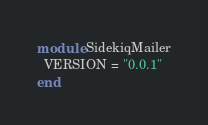<code> <loc_0><loc_0><loc_500><loc_500><_Ruby_>module SidekiqMailer
  VERSION = "0.0.1"
end
</code> 